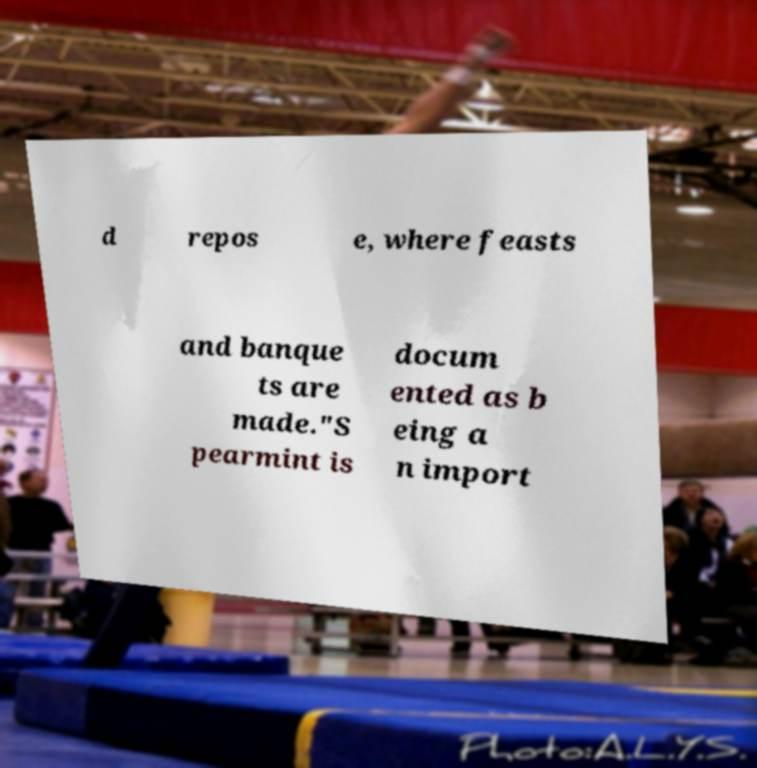For documentation purposes, I need the text within this image transcribed. Could you provide that? d repos e, where feasts and banque ts are made."S pearmint is docum ented as b eing a n import 